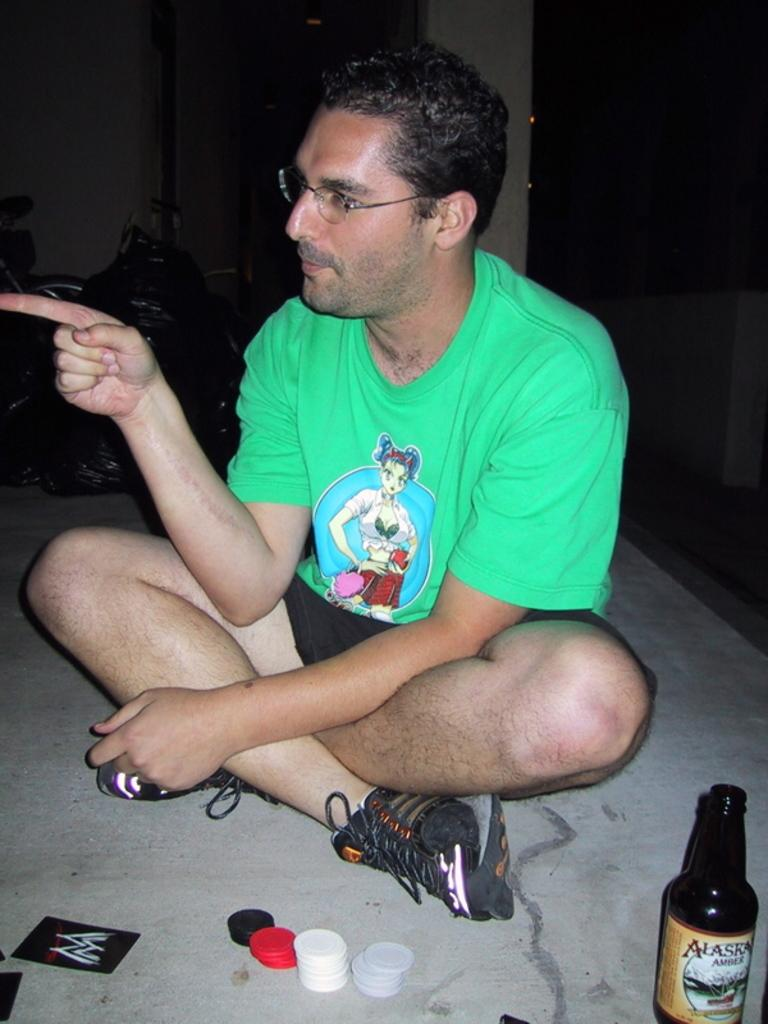What is the man in the image doing? The man is sitting on the floor in the image. What can be seen in the background of the image? There is a beverage bottle, playing coins, polythene bags, and walls visible in the background of the image. What type of hat is the man wearing during his breakfast in the image? There is no hat visible in the image, and the man is not shown eating breakfast. 